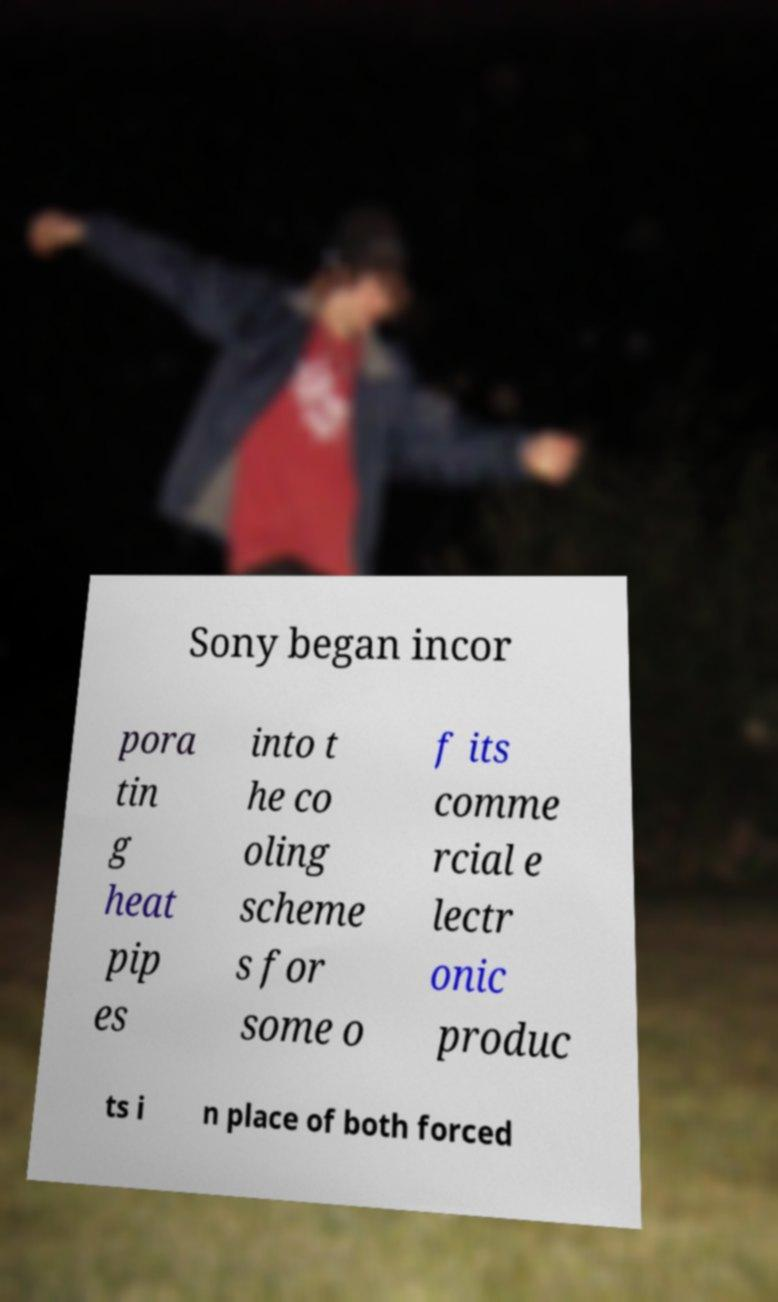I need the written content from this picture converted into text. Can you do that? Sony began incor pora tin g heat pip es into t he co oling scheme s for some o f its comme rcial e lectr onic produc ts i n place of both forced 